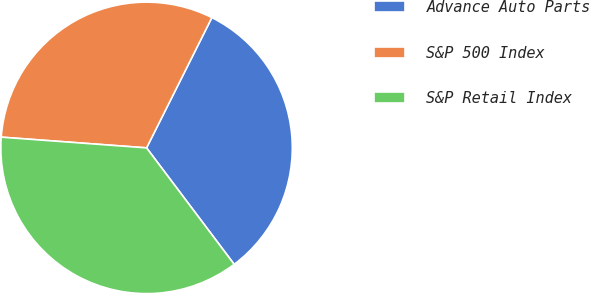Convert chart. <chart><loc_0><loc_0><loc_500><loc_500><pie_chart><fcel>Advance Auto Parts<fcel>S&P 500 Index<fcel>S&P Retail Index<nl><fcel>32.34%<fcel>31.22%<fcel>36.44%<nl></chart> 